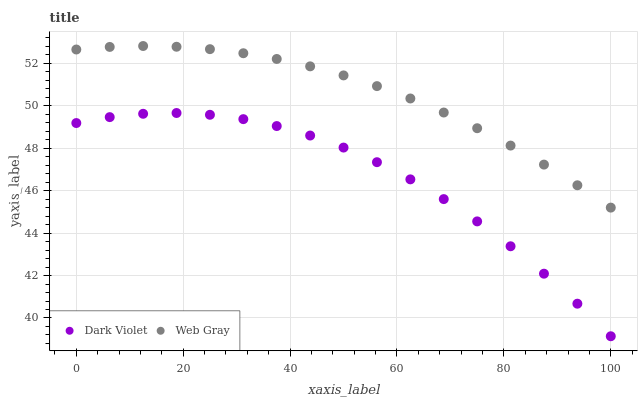Does Dark Violet have the minimum area under the curve?
Answer yes or no. Yes. Does Web Gray have the maximum area under the curve?
Answer yes or no. Yes. Does Dark Violet have the maximum area under the curve?
Answer yes or no. No. Is Web Gray the smoothest?
Answer yes or no. Yes. Is Dark Violet the roughest?
Answer yes or no. Yes. Is Dark Violet the smoothest?
Answer yes or no. No. Does Dark Violet have the lowest value?
Answer yes or no. Yes. Does Web Gray have the highest value?
Answer yes or no. Yes. Does Dark Violet have the highest value?
Answer yes or no. No. Is Dark Violet less than Web Gray?
Answer yes or no. Yes. Is Web Gray greater than Dark Violet?
Answer yes or no. Yes. Does Dark Violet intersect Web Gray?
Answer yes or no. No. 